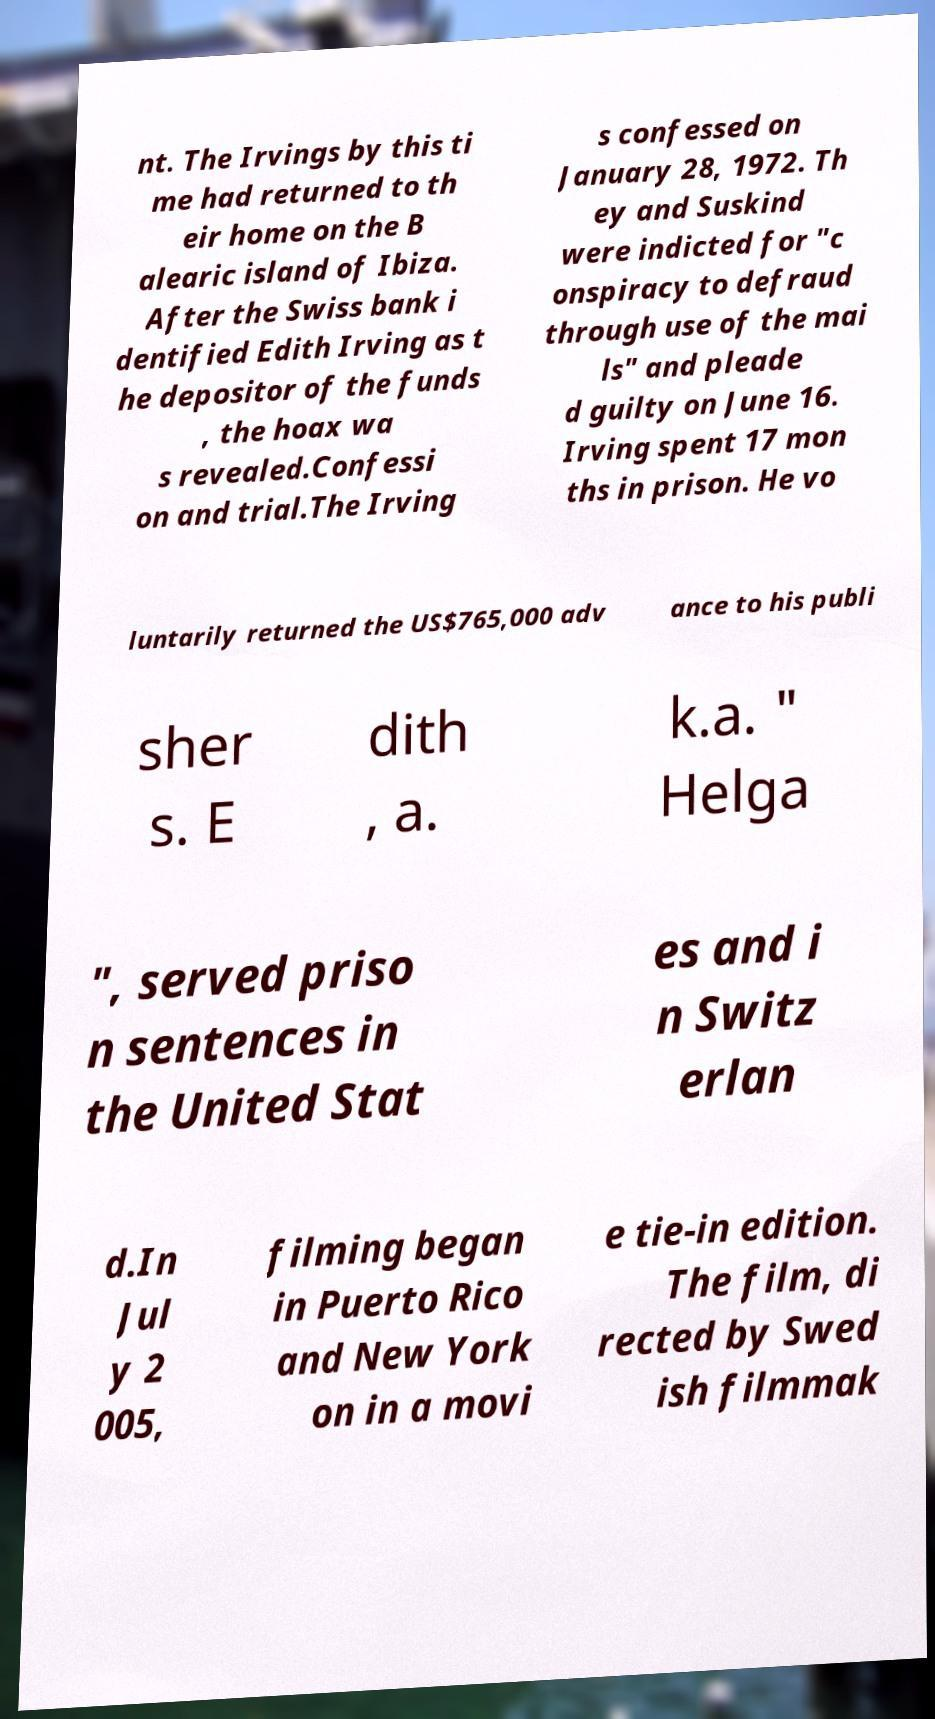Could you assist in decoding the text presented in this image and type it out clearly? nt. The Irvings by this ti me had returned to th eir home on the B alearic island of Ibiza. After the Swiss bank i dentified Edith Irving as t he depositor of the funds , the hoax wa s revealed.Confessi on and trial.The Irving s confessed on January 28, 1972. Th ey and Suskind were indicted for "c onspiracy to defraud through use of the mai ls" and pleade d guilty on June 16. Irving spent 17 mon ths in prison. He vo luntarily returned the US$765,000 adv ance to his publi sher s. E dith , a. k.a. " Helga ", served priso n sentences in the United Stat es and i n Switz erlan d.In Jul y 2 005, filming began in Puerto Rico and New York on in a movi e tie-in edition. The film, di rected by Swed ish filmmak 